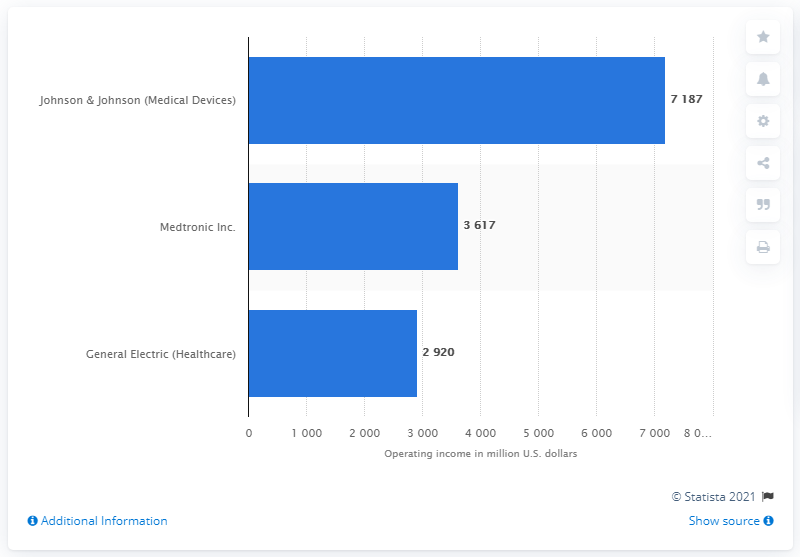Mention a couple of crucial points in this snapshot. Medtronic, Inc. reported an operating profit of 3,617 million US dollars in 2012. 